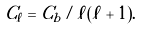Convert formula to latex. <formula><loc_0><loc_0><loc_500><loc_500>C _ { \ell } = C _ { b } / \ell ( \ell + 1 ) .</formula> 